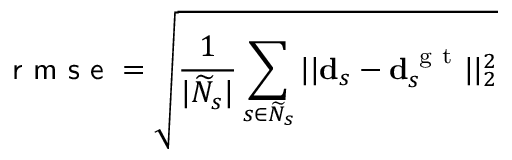<formula> <loc_0><loc_0><loc_500><loc_500>r m s e = \sqrt { \frac { 1 } { | \widetilde { N } _ { s } | } \sum _ { s \in \widetilde { N } _ { s } } | | d _ { s } - d _ { s } ^ { g t } | | _ { 2 } ^ { 2 } }</formula> 